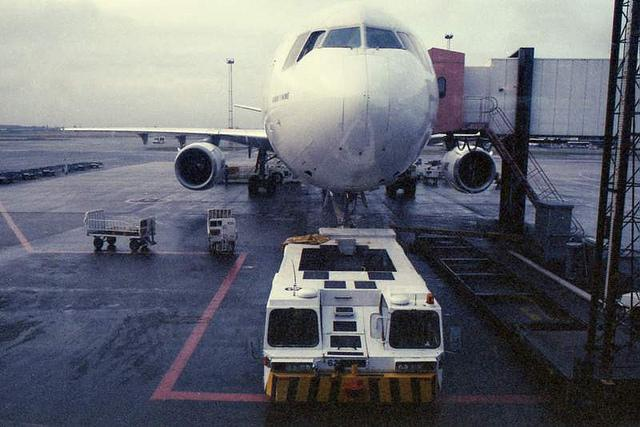The items on the left and right of the front of the biggest vehicle here are called what? wings 